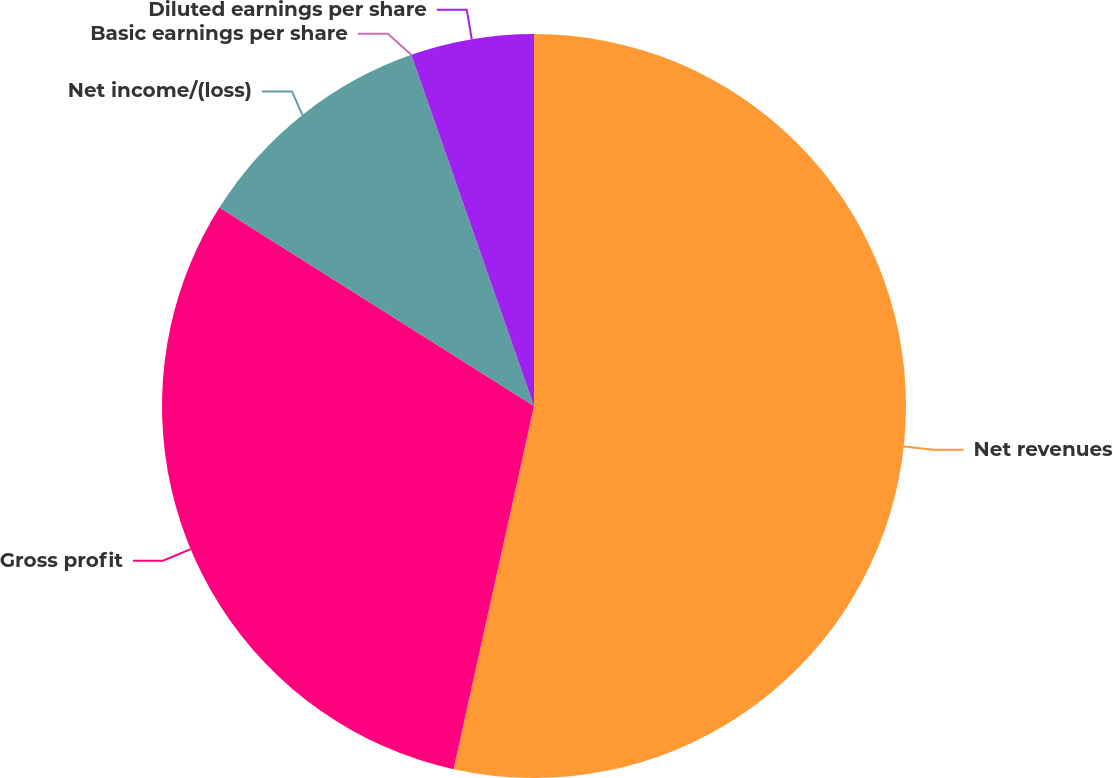Convert chart to OTSL. <chart><loc_0><loc_0><loc_500><loc_500><pie_chart><fcel>Net revenues<fcel>Gross profit<fcel>Net income/(loss)<fcel>Basic earnings per share<fcel>Diluted earnings per share<nl><fcel>53.47%<fcel>30.49%<fcel>10.69%<fcel>0.0%<fcel>5.35%<nl></chart> 